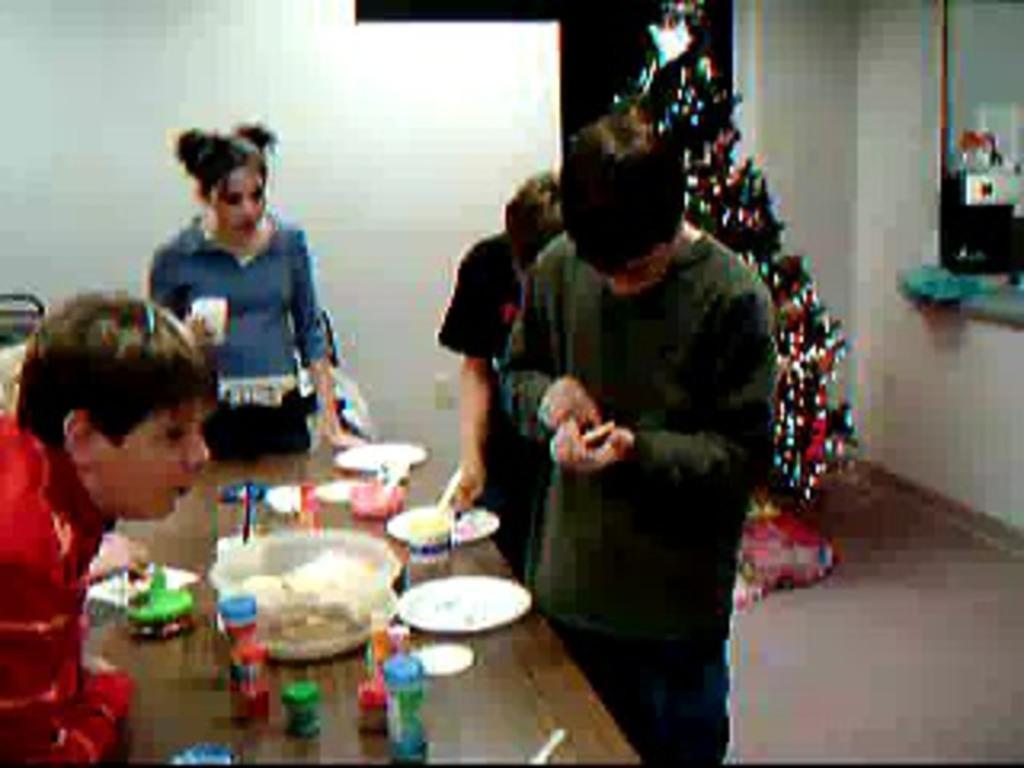How would you summarize this image in a sentence or two? Here we can see that group of people are standing, and in front here is the table and plates and many other objects on it, and here is the wall, and at side here is the x-mass tree. 